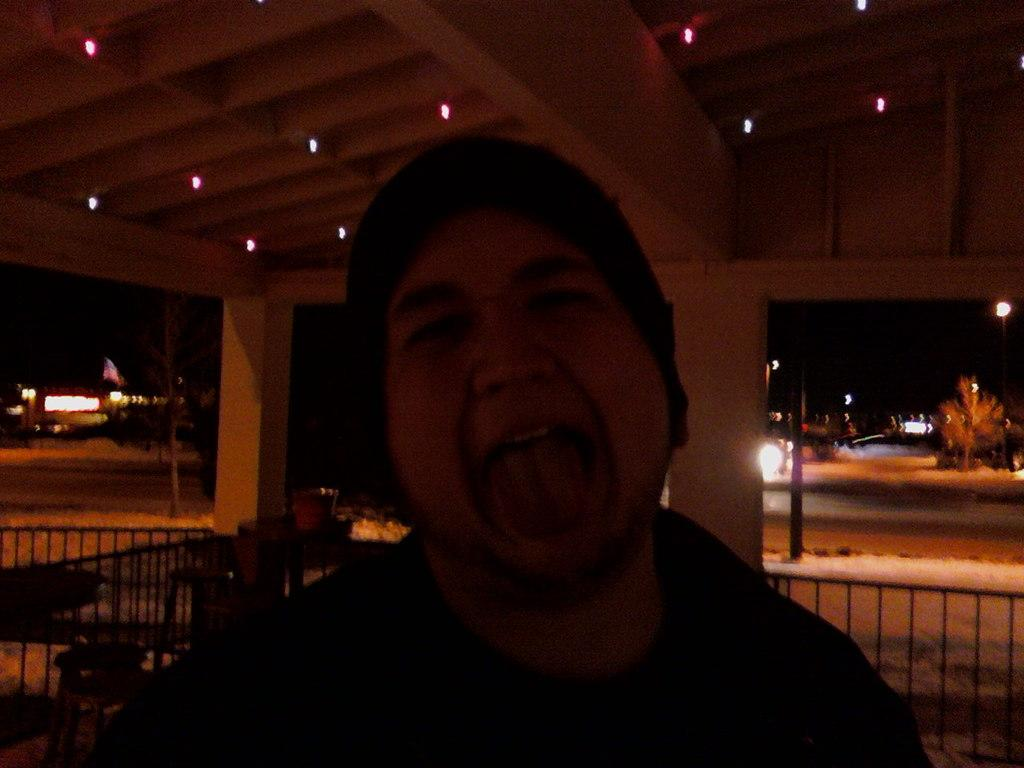What is the main subject of the image? There is a person in the image. What can be seen in the background of the image? In the background, there are pillars, a roof with lights, trees, plants, fencing, a few vehicles, poles, and lights. The sky is dark. Can you describe the ground in the image? The ground is visible in the image. How many bushes are present in the image? There are no bushes mentioned or visible in the image. 